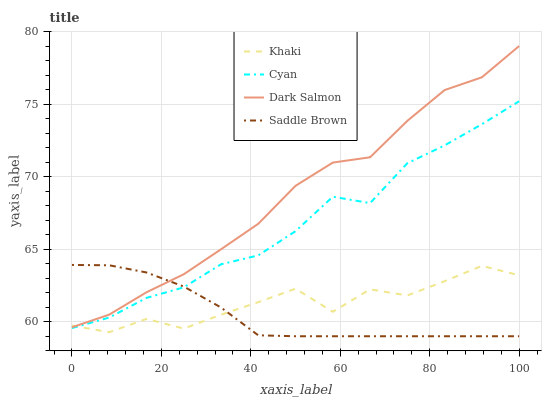Does Saddle Brown have the minimum area under the curve?
Answer yes or no. Yes. Does Dark Salmon have the maximum area under the curve?
Answer yes or no. Yes. Does Khaki have the minimum area under the curve?
Answer yes or no. No. Does Khaki have the maximum area under the curve?
Answer yes or no. No. Is Saddle Brown the smoothest?
Answer yes or no. Yes. Is Khaki the roughest?
Answer yes or no. Yes. Is Dark Salmon the smoothest?
Answer yes or no. No. Is Dark Salmon the roughest?
Answer yes or no. No. Does Saddle Brown have the lowest value?
Answer yes or no. Yes. Does Khaki have the lowest value?
Answer yes or no. No. Does Dark Salmon have the highest value?
Answer yes or no. Yes. Does Khaki have the highest value?
Answer yes or no. No. Is Cyan less than Dark Salmon?
Answer yes or no. Yes. Is Dark Salmon greater than Cyan?
Answer yes or no. Yes. Does Dark Salmon intersect Khaki?
Answer yes or no. Yes. Is Dark Salmon less than Khaki?
Answer yes or no. No. Is Dark Salmon greater than Khaki?
Answer yes or no. No. Does Cyan intersect Dark Salmon?
Answer yes or no. No. 